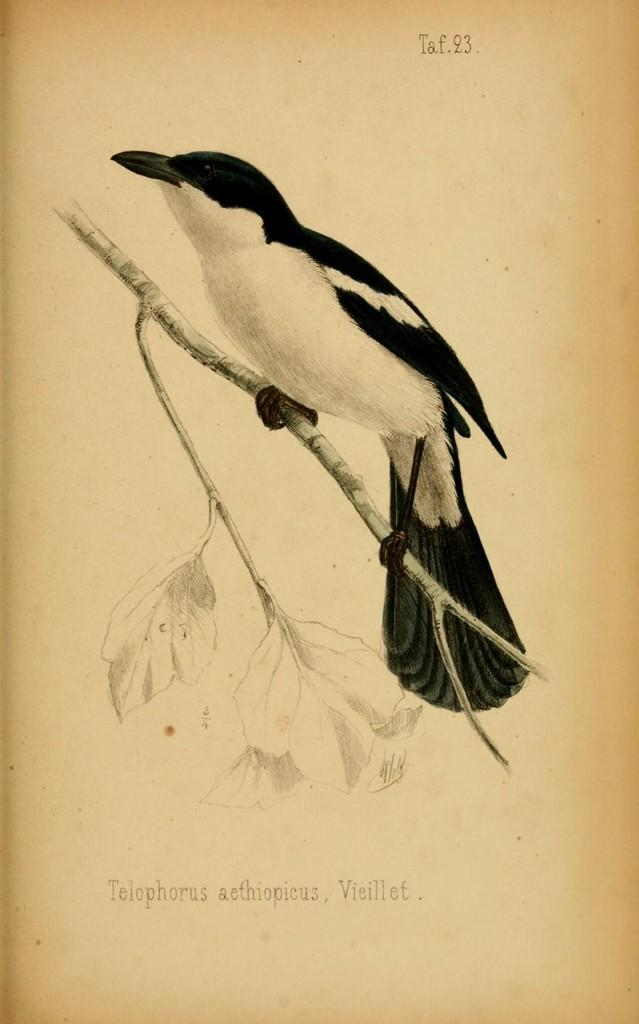What type of animal can be seen in the image? There is a bird in the image. Where is the bird located? The bird is sitting on a branch. What is the branch a part of? The branch is part of a tree. What is the color scheme of the image? The image is in black and white. What type of underwear is the bird wearing in the image? Birds do not wear underwear, and there is no underwear present in the image. What year is depicted in the image? The image does not depict a specific year, as it is a black and white photograph of a bird on a branch. 